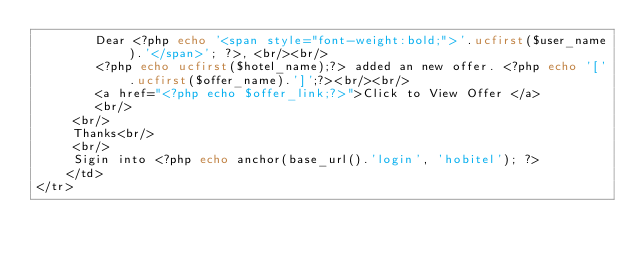<code> <loc_0><loc_0><loc_500><loc_500><_PHP_>		Dear <?php echo '<span style="font-weight:bold;">'.ucfirst($user_name).'</span>'; ?>, <br/><br/>
		<?php echo ucfirst($hotel_name);?> added an new offer. <?php echo '['.ucfirst($offer_name).']';?><br/><br/>
		<a href="<?php echo $offer_link;?>">Click to View Offer </a>
		<br/>
	 <br/>
	 Thanks<br/>
	 <br/>
	 Sigin into <?php echo anchor(base_url().'login', 'hobitel'); ?>
	</td>        
</tr></code> 